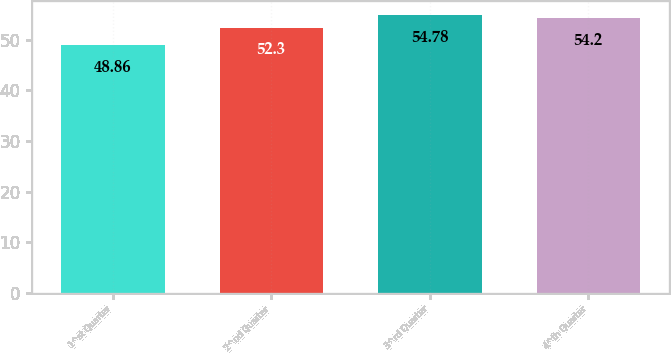Convert chart to OTSL. <chart><loc_0><loc_0><loc_500><loc_500><bar_chart><fcel>1^st Quarter<fcel>2^nd Quarter<fcel>3^rd Quarter<fcel>4^th Quarter<nl><fcel>48.86<fcel>52.3<fcel>54.78<fcel>54.2<nl></chart> 